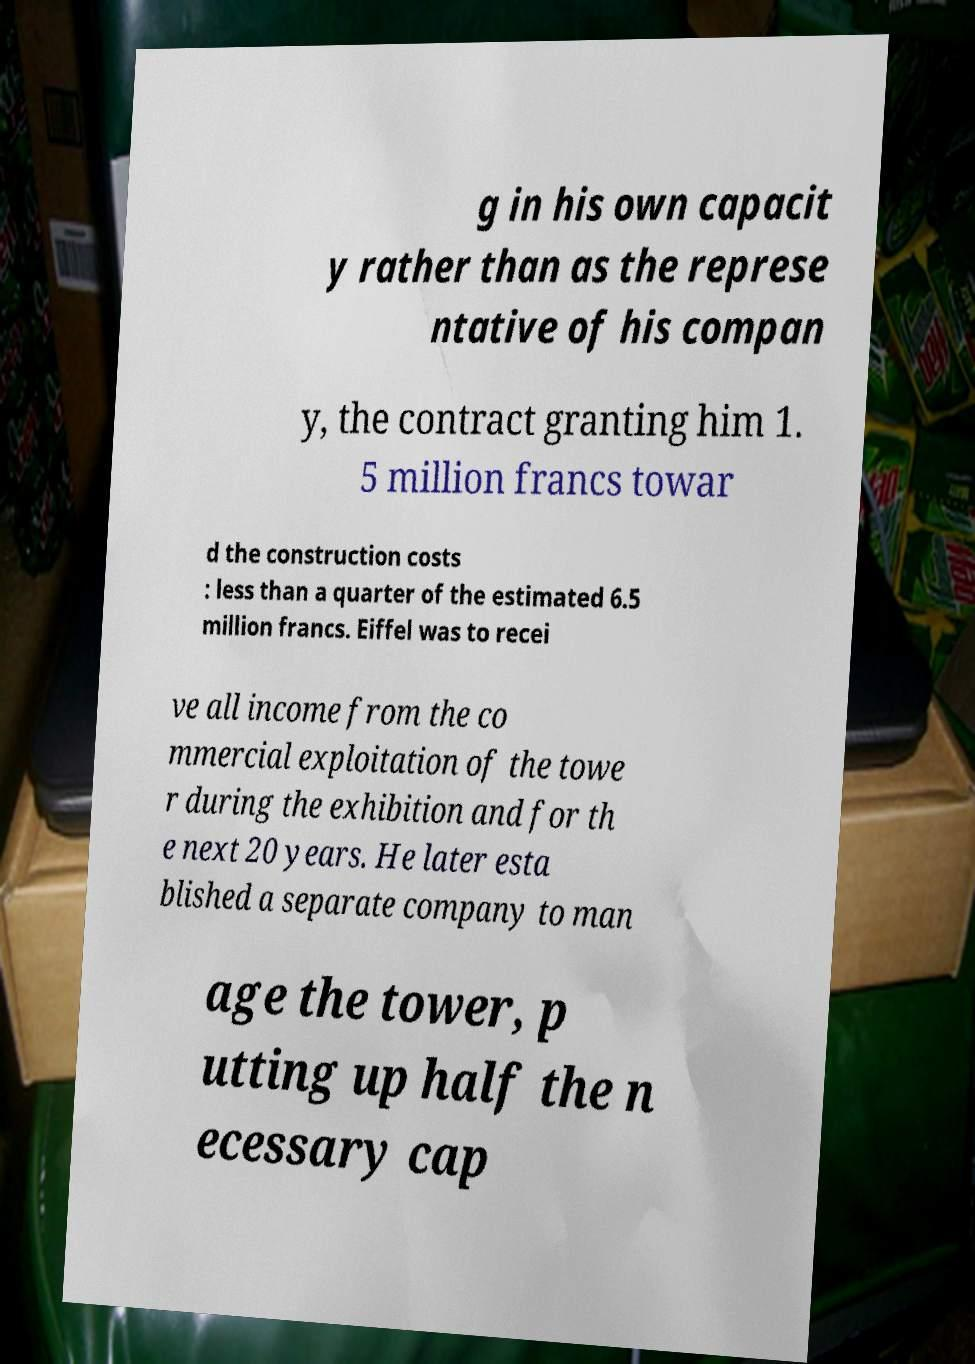What messages or text are displayed in this image? I need them in a readable, typed format. g in his own capacit y rather than as the represe ntative of his compan y, the contract granting him 1. 5 million francs towar d the construction costs : less than a quarter of the estimated 6.5 million francs. Eiffel was to recei ve all income from the co mmercial exploitation of the towe r during the exhibition and for th e next 20 years. He later esta blished a separate company to man age the tower, p utting up half the n ecessary cap 